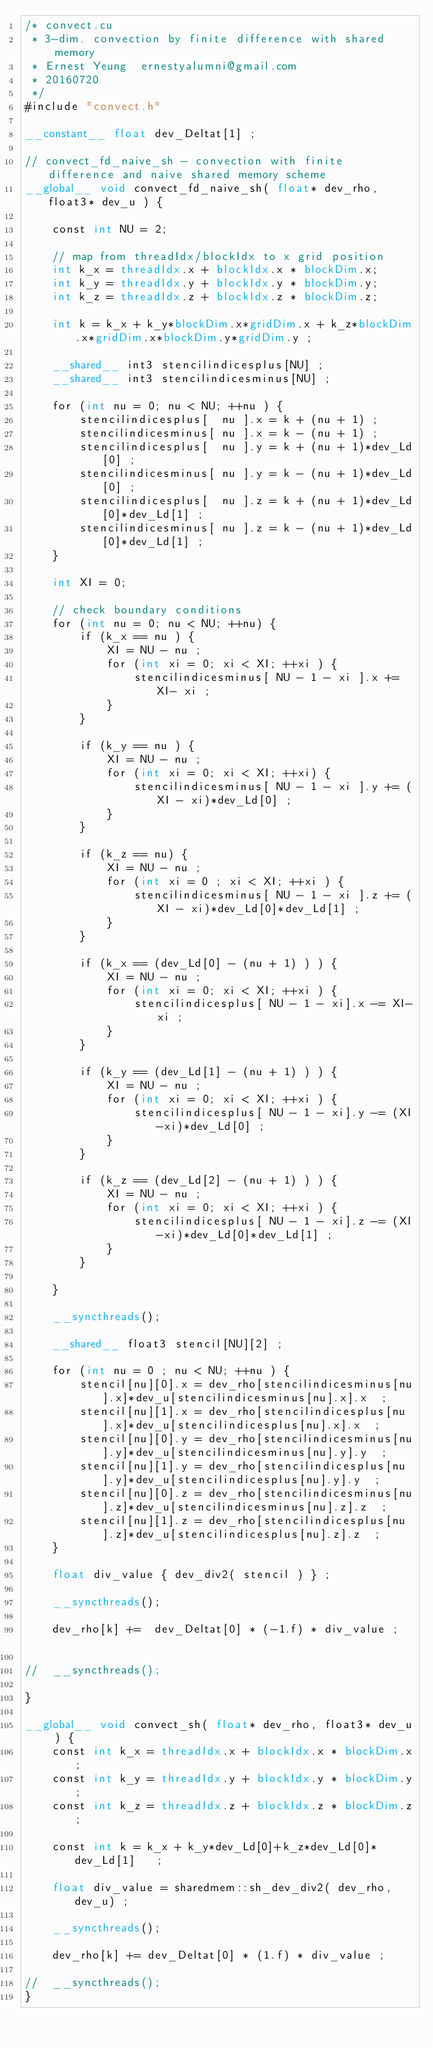<code> <loc_0><loc_0><loc_500><loc_500><_Cuda_>/* convect.cu
 * 3-dim. convection by finite difference with shared memory
 * Ernest Yeung  ernestyalumni@gmail.com
 * 20160720
 */
#include "convect.h"

__constant__ float dev_Deltat[1] ;

// convect_fd_naive_sh - convection with finite difference and naive shared memory scheme
__global__ void convect_fd_naive_sh( float* dev_rho, float3* dev_u ) {

	const int NU = 2;
	
	// map from threadIdx/blockIdx to x grid position
	int k_x = threadIdx.x + blockIdx.x * blockDim.x;
	int k_y = threadIdx.y + blockIdx.y * blockDim.y;
	int k_z = threadIdx.z + blockIdx.z * blockDim.z;
	
	int k = k_x + k_y*blockDim.x*gridDim.x + k_z*blockDim.x*gridDim.x*blockDim.y*gridDim.y ;

	__shared__ int3 stencilindicesplus[NU] ;
	__shared__ int3 stencilindicesminus[NU] ;

	for (int nu = 0; nu < NU; ++nu ) {
		stencilindicesplus[  nu ].x = k + (nu + 1) ; 
		stencilindicesminus[ nu ].x = k - (nu + 1) ; 
		stencilindicesplus[  nu ].y = k + (nu + 1)*dev_Ld[0] ; 
		stencilindicesminus[ nu ].y = k - (nu + 1)*dev_Ld[0] ; 
		stencilindicesplus[  nu ].z = k + (nu + 1)*dev_Ld[0]*dev_Ld[1] ; 
		stencilindicesminus[ nu ].z = k - (nu + 1)*dev_Ld[0]*dev_Ld[1] ; 
	}

	int XI = 0;

	// check boundary conditions
	for (int nu = 0; nu < NU; ++nu) {
		if (k_x == nu ) {
			XI = NU - nu ;
			for (int xi = 0; xi < XI; ++xi ) {
				stencilindicesminus[ NU - 1 - xi ].x += XI- xi ;  
			}
		}
	
		if (k_y == nu ) {
			XI = NU - nu ;
			for (int xi = 0; xi < XI; ++xi) { 
				stencilindicesminus[ NU - 1 - xi ].y += (XI - xi)*dev_Ld[0] ;
			}
		}
		
		if (k_z == nu) {
			XI = NU - nu ;
			for (int xi = 0 ; xi < XI; ++xi ) {
				stencilindicesminus[ NU - 1 - xi ].z += (XI - xi)*dev_Ld[0]*dev_Ld[1] ;  
			}
		}
	
		if (k_x == (dev_Ld[0] - (nu + 1) ) ) {
			XI = NU - nu ;
			for (int xi = 0; xi < XI; ++xi ) {
				stencilindicesplus[ NU - 1 - xi].x -= XI-xi ;
			}
		}
		
		if (k_y == (dev_Ld[1] - (nu + 1) ) ) {
			XI = NU - nu ;
			for (int xi = 0; xi < XI; ++xi ) {
				stencilindicesplus[ NU - 1 - xi].y -= (XI-xi)*dev_Ld[0] ;
			}
		}
		
		if (k_z == (dev_Ld[2] - (nu + 1) ) ) {
			XI = NU - nu ;
			for (int xi = 0; xi < XI; ++xi ) {
				stencilindicesplus[ NU - 1 - xi].z -= (XI-xi)*dev_Ld[0]*dev_Ld[1] ;
			}
		}
		
	}

	__syncthreads();
	
	__shared__ float3 stencil[NU][2] ; 
	
	for (int nu = 0 ; nu < NU; ++nu ) {
		stencil[nu][0].x = dev_rho[stencilindicesminus[nu].x]*dev_u[stencilindicesminus[nu].x].x  ;
		stencil[nu][1].x = dev_rho[stencilindicesplus[nu].x]*dev_u[stencilindicesplus[nu].x].x  ;
		stencil[nu][0].y = dev_rho[stencilindicesminus[nu].y]*dev_u[stencilindicesminus[nu].y].y  ;
		stencil[nu][1].y = dev_rho[stencilindicesplus[nu].y]*dev_u[stencilindicesplus[nu].y].y  ;
		stencil[nu][0].z = dev_rho[stencilindicesminus[nu].z]*dev_u[stencilindicesminus[nu].z].z  ;
		stencil[nu][1].z = dev_rho[stencilindicesplus[nu].z]*dev_u[stencilindicesplus[nu].z].z  ;
	}	
	
	float div_value { dev_div2( stencil ) } ;
	
	__syncthreads();
	
	dev_rho[k] +=  dev_Deltat[0] * (-1.f) * div_value ;		
			
//	__syncthreads();		
			
}

__global__ void convect_sh( float* dev_rho, float3* dev_u ) {
	const int k_x = threadIdx.x + blockIdx.x * blockDim.x; 
	const int k_y = threadIdx.y + blockIdx.y * blockDim.y; 
	const int k_z = threadIdx.z + blockIdx.z * blockDim.z; 
	
	const int k = k_x + k_y*dev_Ld[0]+k_z*dev_Ld[0]*dev_Ld[1]   ;
	
	float div_value = sharedmem::sh_dev_div2( dev_rho, dev_u) ;

	__syncthreads();
	
	dev_rho[k] += dev_Deltat[0] * (1.f) * div_value ;

//	__syncthreads();
}





</code> 